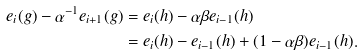Convert formula to latex. <formula><loc_0><loc_0><loc_500><loc_500>e _ { i } ( g ) - \alpha ^ { - 1 } e _ { i + 1 } ( g ) & = e _ { i } ( h ) - \alpha \beta e _ { i - 1 } ( h ) \\ & = e _ { i } ( h ) - e _ { i - 1 } ( h ) + ( 1 - \alpha \beta ) e _ { i - 1 } ( h ) .</formula> 